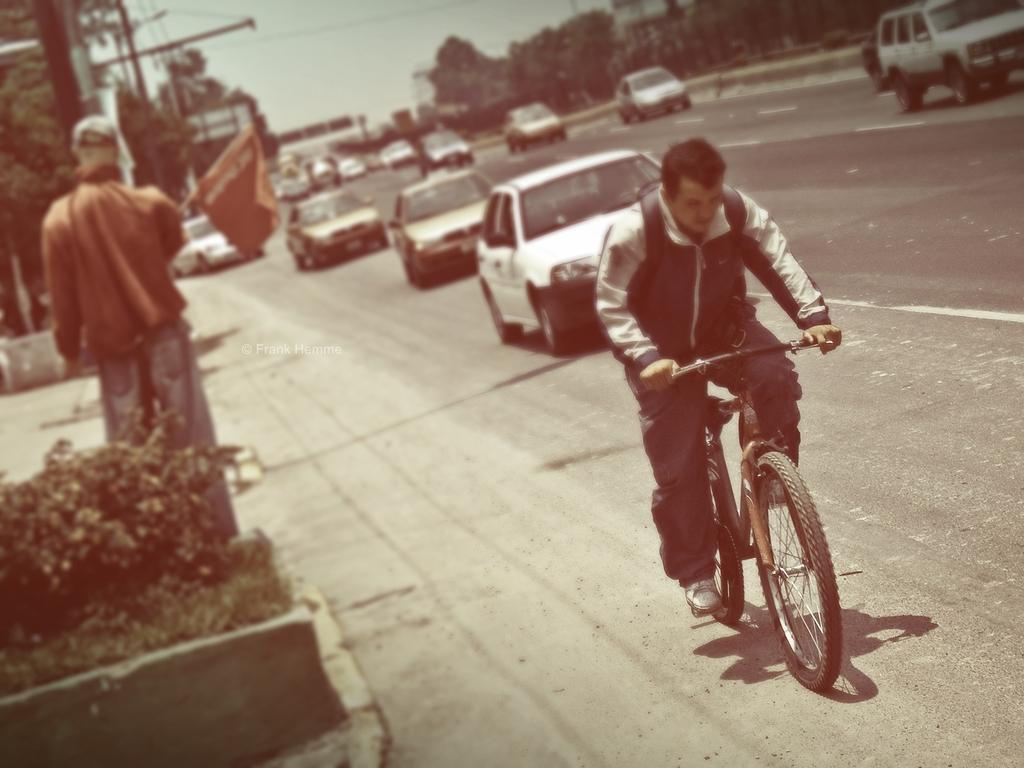What is the man in the image doing? There is a man sitting on a bicycle in the image. What can be seen on the road in the image? There are parked cars on the road in the image. Are there any other people in the image besides the man on the bicycle? Yes, there is a man standing in the image. How many legs does the light have in the image? There is no light present in the image, so it is not possible to determine the number of legs it might have. 